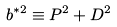<formula> <loc_0><loc_0><loc_500><loc_500>b ^ { * 2 } \equiv P ^ { 2 } + D ^ { 2 }</formula> 